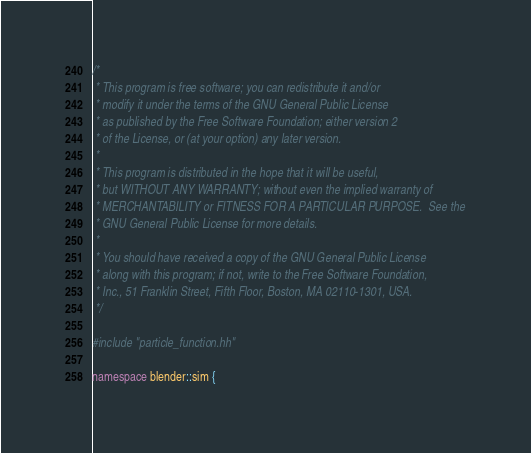<code> <loc_0><loc_0><loc_500><loc_500><_C++_>/*
 * This program is free software; you can redistribute it and/or
 * modify it under the terms of the GNU General Public License
 * as published by the Free Software Foundation; either version 2
 * of the License, or (at your option) any later version.
 *
 * This program is distributed in the hope that it will be useful,
 * but WITHOUT ANY WARRANTY; without even the implied warranty of
 * MERCHANTABILITY or FITNESS FOR A PARTICULAR PURPOSE.  See the
 * GNU General Public License for more details.
 *
 * You should have received a copy of the GNU General Public License
 * along with this program; if not, write to the Free Software Foundation,
 * Inc., 51 Franklin Street, Fifth Floor, Boston, MA 02110-1301, USA.
 */

#include "particle_function.hh"

namespace blender::sim {
</code> 